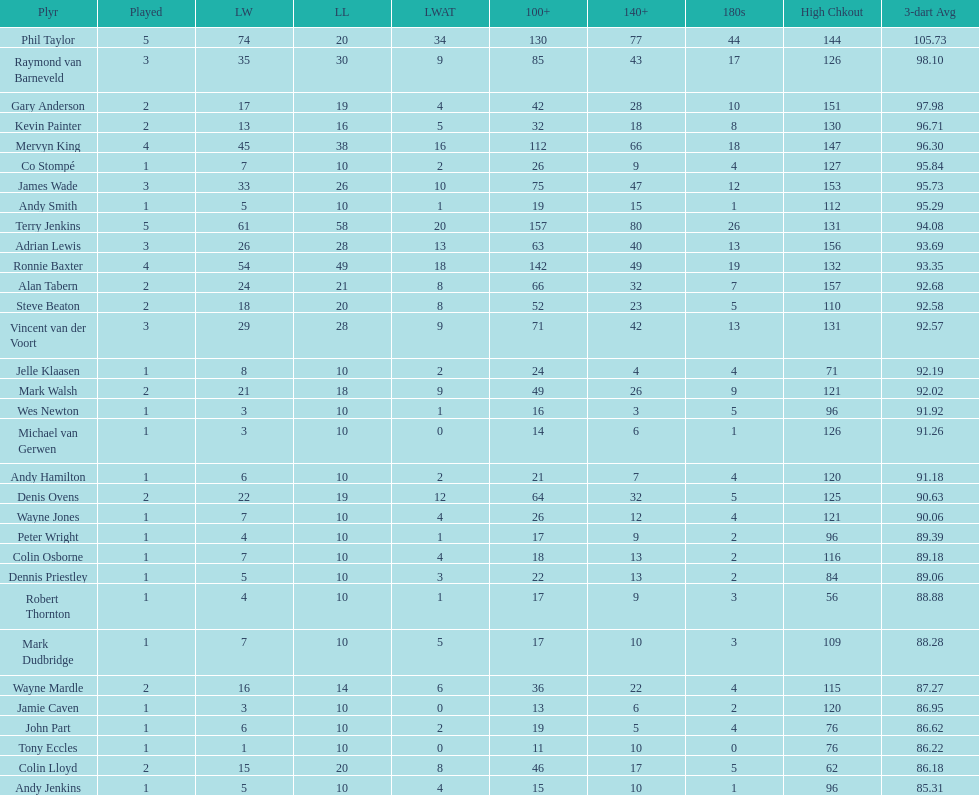How many players in the 2009 world matchplay won at least 30 legs? 6. 